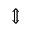<formula> <loc_0><loc_0><loc_500><loc_500>\Updownarrow</formula> 